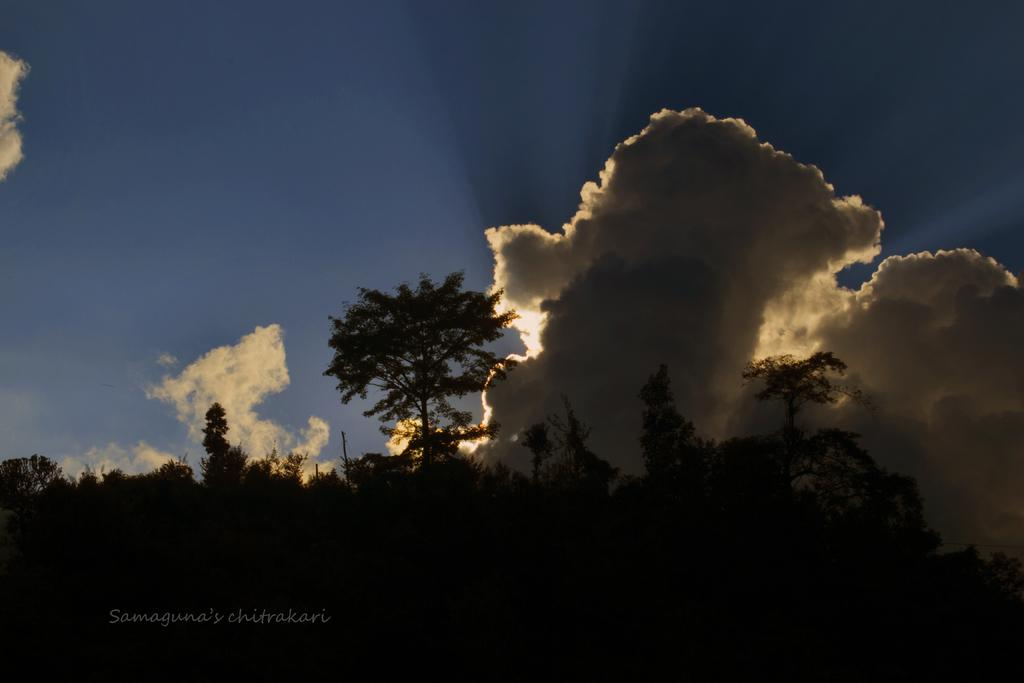What is located in the foreground of the image? There are trees in the foreground of the image. What can be seen in the sky in the image? There are clouds in the sky. How many impulses can be seen in the image? There are no impulses present in the image. What type of rose is growing near the trees in the image? There are no roses present in the image; only trees are visible in the foreground. 